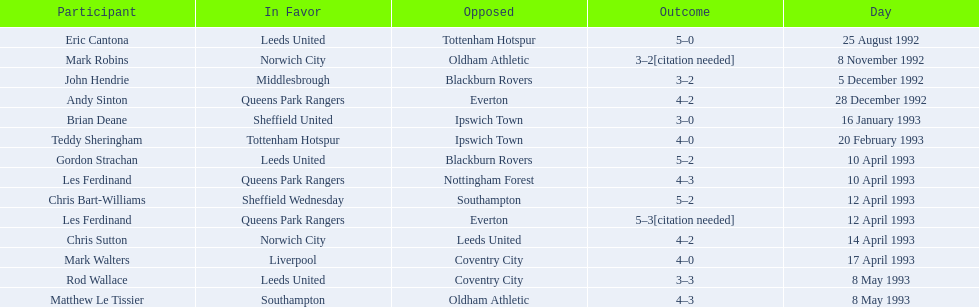Could you parse the entire table? {'header': ['Participant', 'In Favor', 'Opposed', 'Outcome', 'Day'], 'rows': [['Eric Cantona', 'Leeds United', 'Tottenham Hotspur', '5–0', '25 August 1992'], ['Mark Robins', 'Norwich City', 'Oldham Athletic', '3–2[citation needed]', '8 November 1992'], ['John Hendrie', 'Middlesbrough', 'Blackburn Rovers', '3–2', '5 December 1992'], ['Andy Sinton', 'Queens Park Rangers', 'Everton', '4–2', '28 December 1992'], ['Brian Deane', 'Sheffield United', 'Ipswich Town', '3–0', '16 January 1993'], ['Teddy Sheringham', 'Tottenham Hotspur', 'Ipswich Town', '4–0', '20 February 1993'], ['Gordon Strachan', 'Leeds United', 'Blackburn Rovers', '5–2', '10 April 1993'], ['Les Ferdinand', 'Queens Park Rangers', 'Nottingham Forest', '4–3', '10 April 1993'], ['Chris Bart-Williams', 'Sheffield Wednesday', 'Southampton', '5–2', '12 April 1993'], ['Les Ferdinand', 'Queens Park Rangers', 'Everton', '5–3[citation needed]', '12 April 1993'], ['Chris Sutton', 'Norwich City', 'Leeds United', '4–2', '14 April 1993'], ['Mark Walters', 'Liverpool', 'Coventry City', '4–0', '17 April 1993'], ['Rod Wallace', 'Leeds United', 'Coventry City', '3–3', '8 May 1993'], ['Matthew Le Tissier', 'Southampton', 'Oldham Athletic', '4–3', '8 May 1993']]} Which player had the same result as mark robins? John Hendrie. 